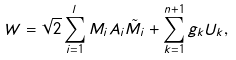<formula> <loc_0><loc_0><loc_500><loc_500>W = \sqrt { 2 } \sum _ { i = 1 } ^ { l } M _ { i } A _ { i } \tilde { M } _ { i } + \sum _ { k = 1 } ^ { n + 1 } g _ { k } U _ { k } ,</formula> 